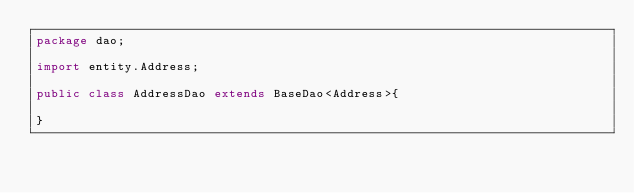Convert code to text. <code><loc_0><loc_0><loc_500><loc_500><_Java_>package dao;

import entity.Address;

public class AddressDao extends BaseDao<Address>{

}
</code> 